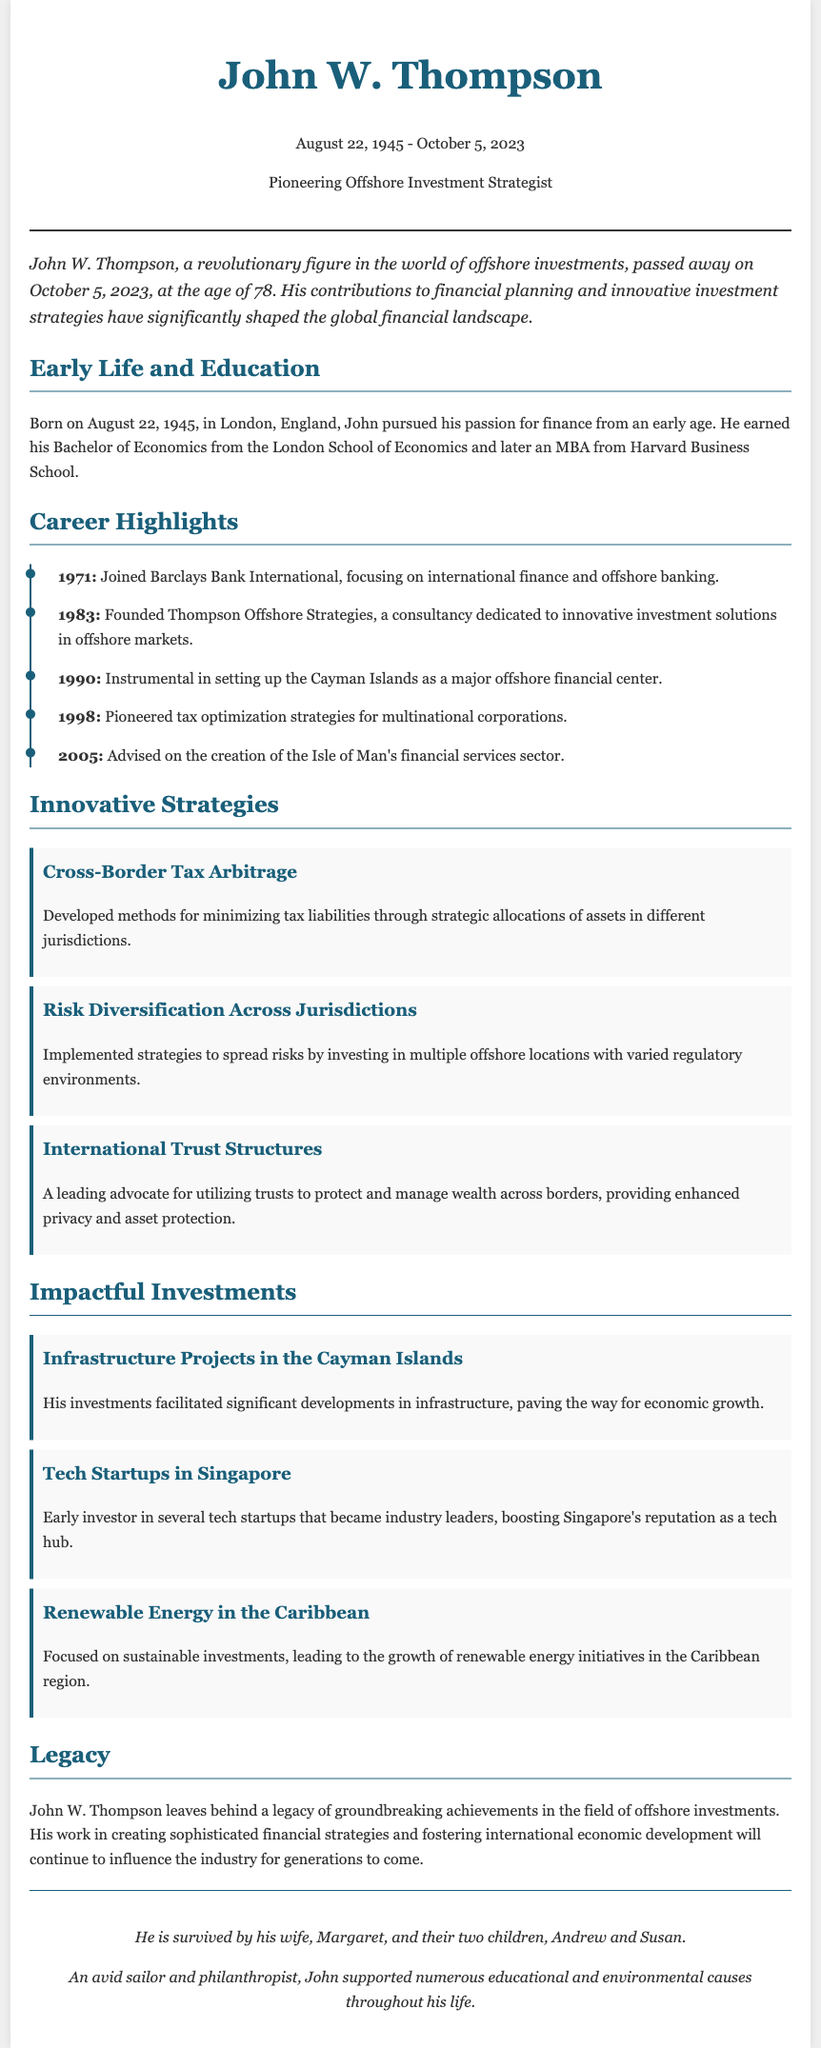What was John W. Thompson's birth date? The document states that John W. Thompson was born on August 22, 1945.
Answer: August 22, 1945 What was the name of the consultancy John founded? The document mentions that he founded Thompson Offshore Strategies.
Answer: Thompson Offshore Strategies In which year did John pioneer tax optimization strategies? The document indicates that he pioneered tax optimization strategies in the year 1998.
Answer: 1998 What is one of the innovative strategies he developed? The document lists "Cross-Border Tax Arbitrage" as one of the innovative strategies.
Answer: Cross-Border Tax Arbitrage Which financial center did John help establish? The document notes he was instrumental in setting up the Cayman Islands as a major offshore financial center.
Answer: Cayman Islands What type of projects did John invest in within the Cayman Islands? The document states he invested in infrastructure projects, leading to significant developments.
Answer: Infrastructure Projects Who survived John W. Thompson? The document states he is survived by his wife, Margaret, and their two children, Andrew and Susan.
Answer: Margaret, Andrew, and Susan What was one focus of John’s impactful investments? The document highlights that he focused on renewable energy initiatives in the Caribbean.
Answer: Renewable Energy in the Caribbean 